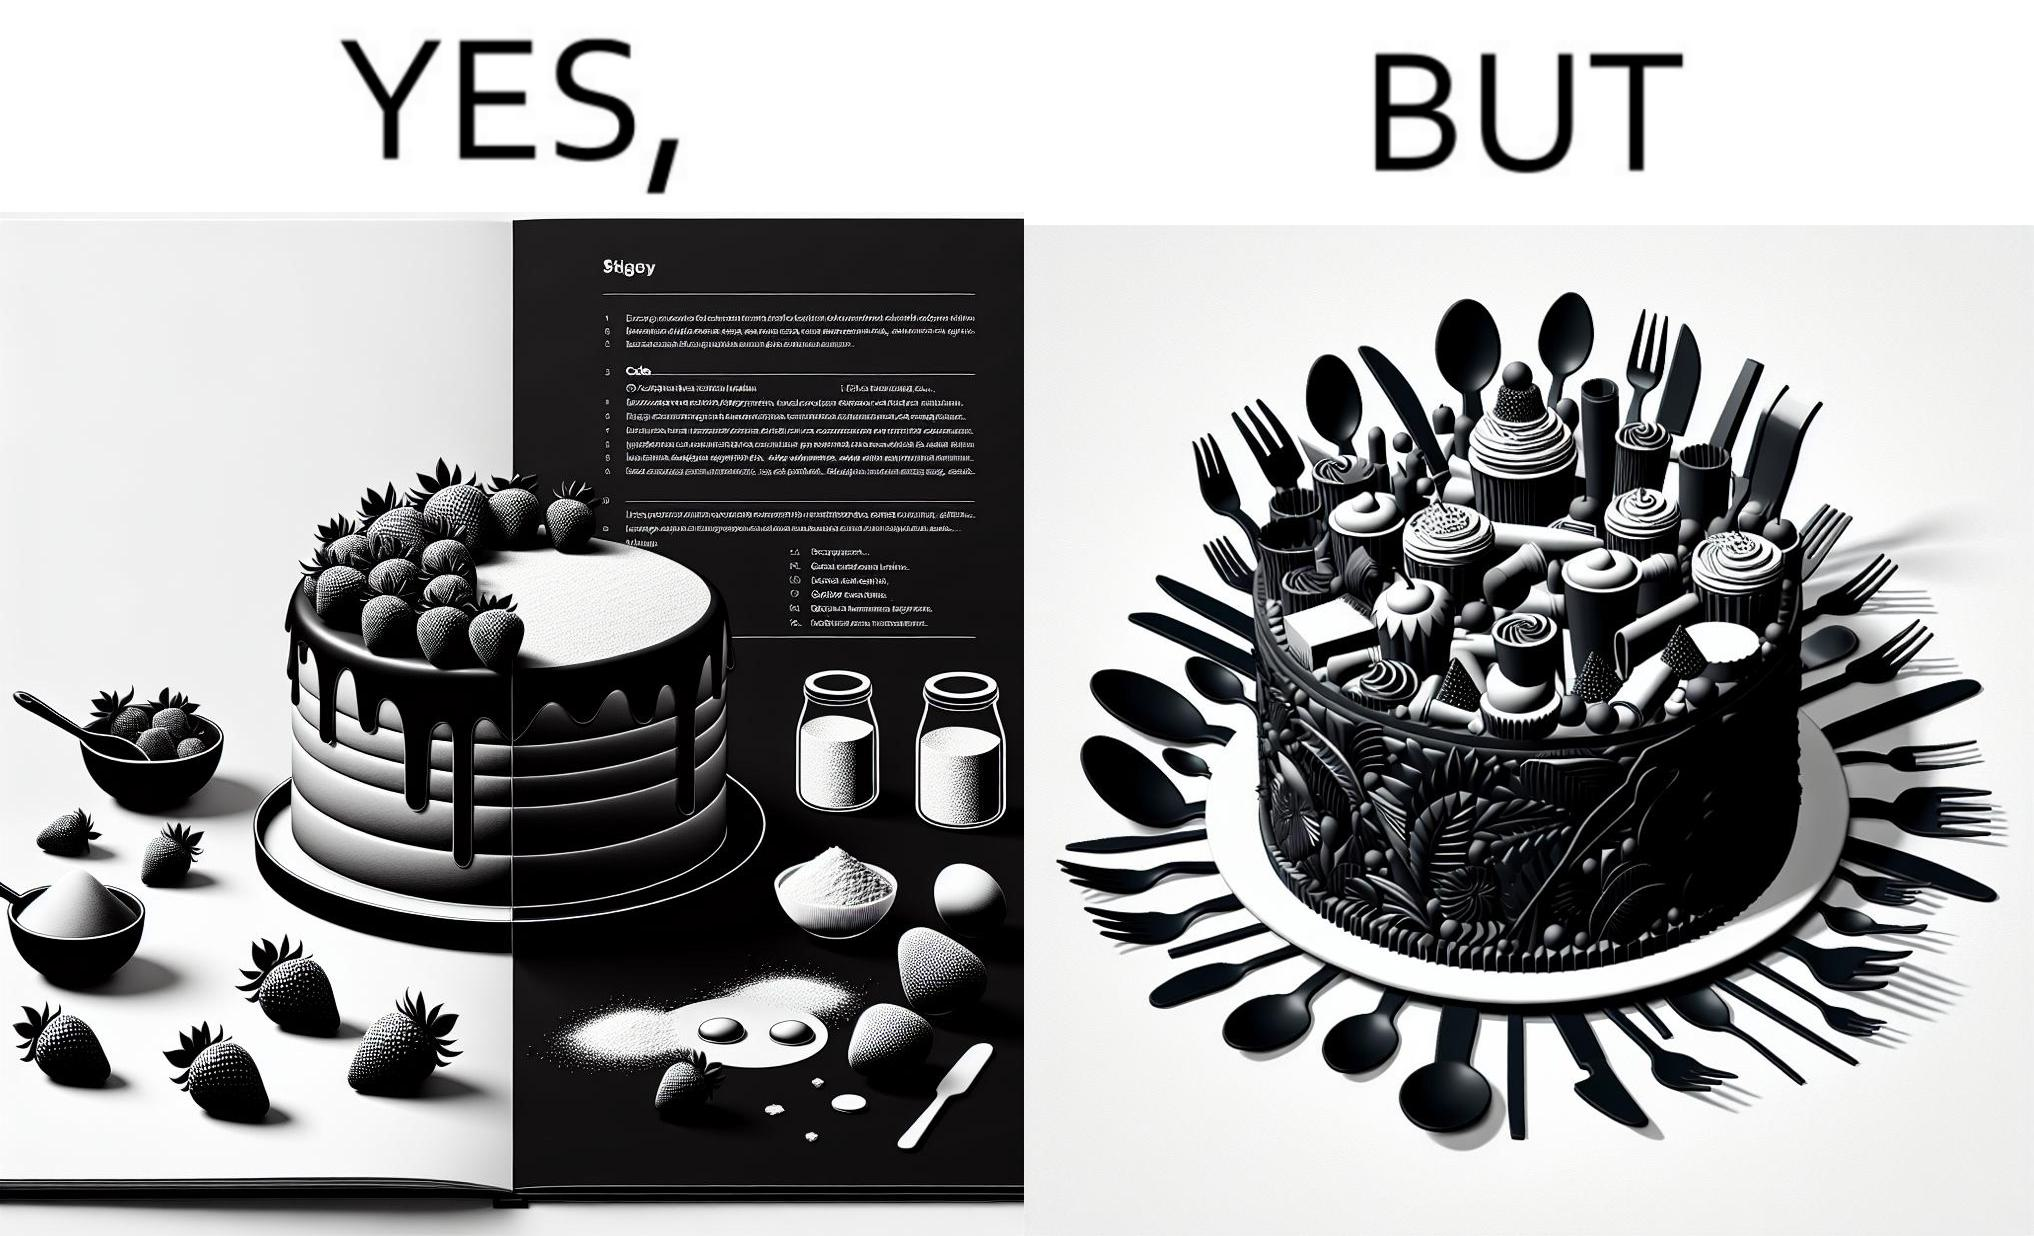Explain why this image is satirical. The image is funny, as when making a strawberry cake using  a recipe book, the outcome is not quite what is expected, and one has to wash the used utensils afterwards as well. 